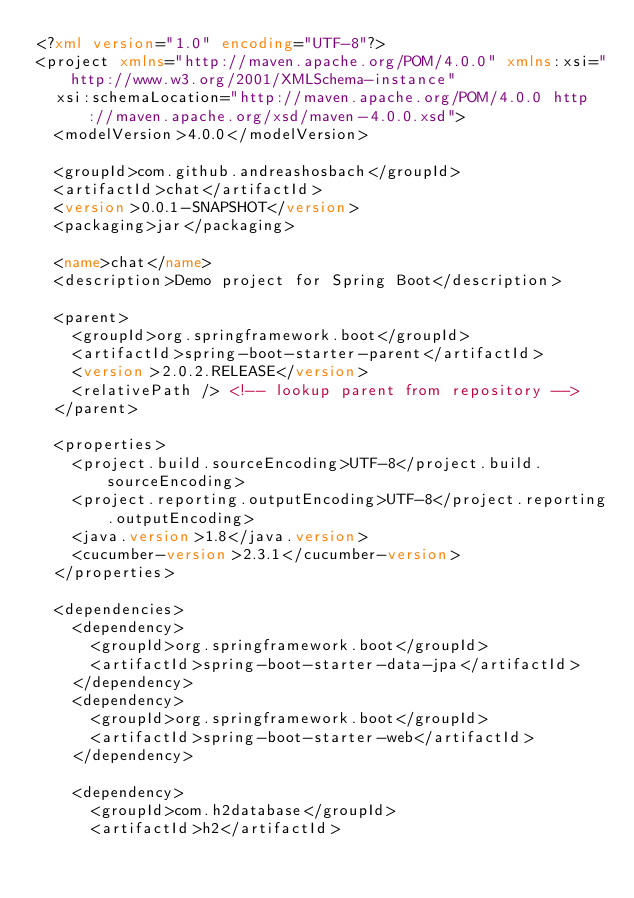<code> <loc_0><loc_0><loc_500><loc_500><_XML_><?xml version="1.0" encoding="UTF-8"?>
<project xmlns="http://maven.apache.org/POM/4.0.0" xmlns:xsi="http://www.w3.org/2001/XMLSchema-instance"
	xsi:schemaLocation="http://maven.apache.org/POM/4.0.0 http://maven.apache.org/xsd/maven-4.0.0.xsd">
	<modelVersion>4.0.0</modelVersion>

	<groupId>com.github.andreashosbach</groupId>
	<artifactId>chat</artifactId>
	<version>0.0.1-SNAPSHOT</version>
	<packaging>jar</packaging>

	<name>chat</name>
	<description>Demo project for Spring Boot</description>

	<parent>
		<groupId>org.springframework.boot</groupId>
		<artifactId>spring-boot-starter-parent</artifactId>
		<version>2.0.2.RELEASE</version>
		<relativePath /> <!-- lookup parent from repository -->
	</parent>

	<properties>
		<project.build.sourceEncoding>UTF-8</project.build.sourceEncoding>
		<project.reporting.outputEncoding>UTF-8</project.reporting.outputEncoding>
		<java.version>1.8</java.version>
		<cucumber-version>2.3.1</cucumber-version>
	</properties>

	<dependencies>
		<dependency>
			<groupId>org.springframework.boot</groupId>
			<artifactId>spring-boot-starter-data-jpa</artifactId>
		</dependency>
		<dependency>
			<groupId>org.springframework.boot</groupId>
			<artifactId>spring-boot-starter-web</artifactId>
		</dependency>

		<dependency>
			<groupId>com.h2database</groupId>
			<artifactId>h2</artifactId></code> 